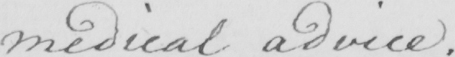What does this handwritten line say? medical advice . 